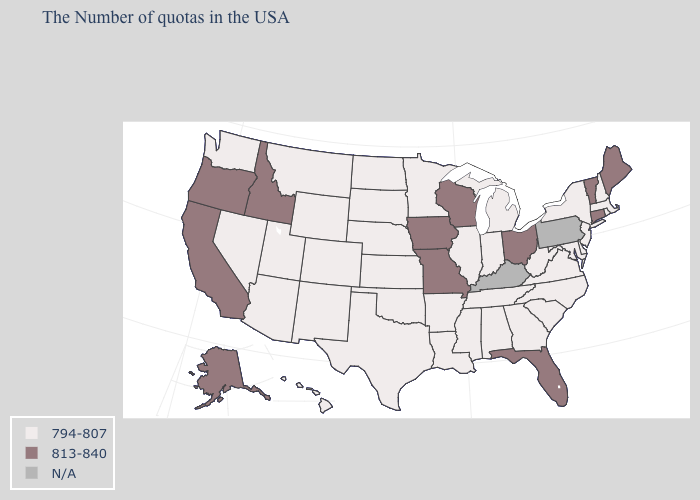Which states have the lowest value in the South?
Write a very short answer. Delaware, Maryland, Virginia, North Carolina, South Carolina, West Virginia, Georgia, Alabama, Tennessee, Mississippi, Louisiana, Arkansas, Oklahoma, Texas. Name the states that have a value in the range N/A?
Quick response, please. Pennsylvania, Kentucky. Name the states that have a value in the range 794-807?
Write a very short answer. Massachusetts, Rhode Island, New Hampshire, New York, New Jersey, Delaware, Maryland, Virginia, North Carolina, South Carolina, West Virginia, Georgia, Michigan, Indiana, Alabama, Tennessee, Illinois, Mississippi, Louisiana, Arkansas, Minnesota, Kansas, Nebraska, Oklahoma, Texas, South Dakota, North Dakota, Wyoming, Colorado, New Mexico, Utah, Montana, Arizona, Nevada, Washington, Hawaii. Which states hav the highest value in the MidWest?
Keep it brief. Ohio, Wisconsin, Missouri, Iowa. What is the highest value in the West ?
Give a very brief answer. 813-840. What is the value of Pennsylvania?
Keep it brief. N/A. Does the first symbol in the legend represent the smallest category?
Be succinct. Yes. Name the states that have a value in the range 813-840?
Quick response, please. Maine, Vermont, Connecticut, Ohio, Florida, Wisconsin, Missouri, Iowa, Idaho, California, Oregon, Alaska. Name the states that have a value in the range 813-840?
Short answer required. Maine, Vermont, Connecticut, Ohio, Florida, Wisconsin, Missouri, Iowa, Idaho, California, Oregon, Alaska. What is the highest value in the South ?
Quick response, please. 813-840. Does Michigan have the lowest value in the USA?
Write a very short answer. Yes. Name the states that have a value in the range 794-807?
Answer briefly. Massachusetts, Rhode Island, New Hampshire, New York, New Jersey, Delaware, Maryland, Virginia, North Carolina, South Carolina, West Virginia, Georgia, Michigan, Indiana, Alabama, Tennessee, Illinois, Mississippi, Louisiana, Arkansas, Minnesota, Kansas, Nebraska, Oklahoma, Texas, South Dakota, North Dakota, Wyoming, Colorado, New Mexico, Utah, Montana, Arizona, Nevada, Washington, Hawaii. Does the first symbol in the legend represent the smallest category?
Keep it brief. Yes. 